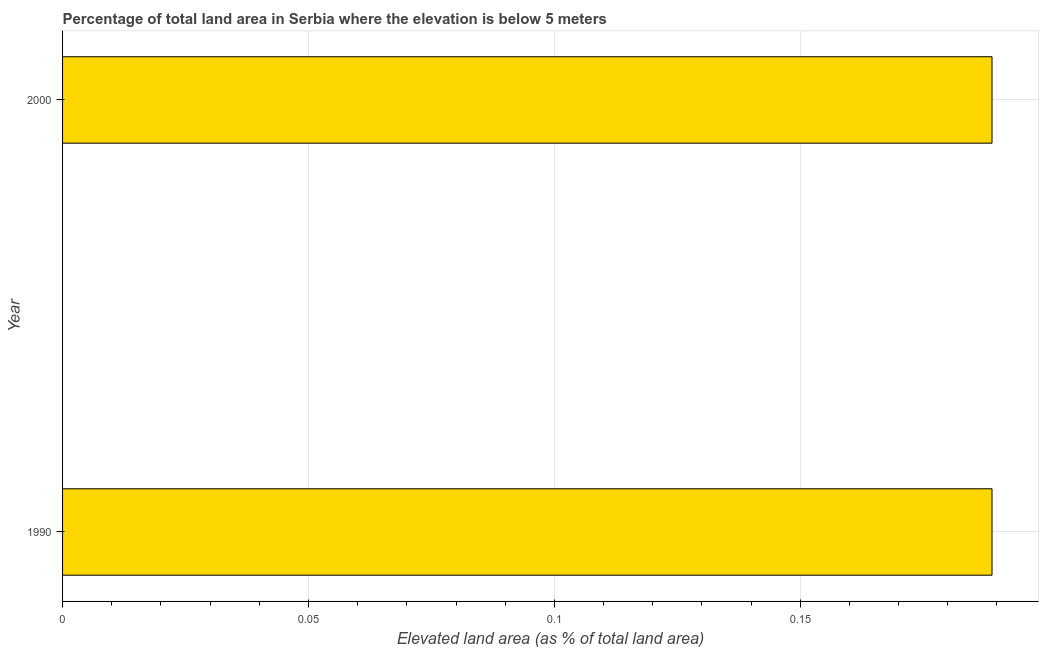Does the graph contain any zero values?
Give a very brief answer. No. What is the title of the graph?
Your answer should be compact. Percentage of total land area in Serbia where the elevation is below 5 meters. What is the label or title of the X-axis?
Make the answer very short. Elevated land area (as % of total land area). What is the total elevated land area in 1990?
Provide a short and direct response. 0.19. Across all years, what is the maximum total elevated land area?
Your answer should be very brief. 0.19. Across all years, what is the minimum total elevated land area?
Keep it short and to the point. 0.19. In which year was the total elevated land area minimum?
Provide a succinct answer. 1990. What is the sum of the total elevated land area?
Provide a short and direct response. 0.38. What is the average total elevated land area per year?
Give a very brief answer. 0.19. What is the median total elevated land area?
Provide a short and direct response. 0.19. What is the ratio of the total elevated land area in 1990 to that in 2000?
Offer a terse response. 1. In how many years, is the total elevated land area greater than the average total elevated land area taken over all years?
Your response must be concise. 0. Are all the bars in the graph horizontal?
Your answer should be very brief. Yes. How many years are there in the graph?
Make the answer very short. 2. What is the difference between two consecutive major ticks on the X-axis?
Give a very brief answer. 0.05. What is the Elevated land area (as % of total land area) of 1990?
Make the answer very short. 0.19. What is the Elevated land area (as % of total land area) of 2000?
Your answer should be very brief. 0.19. What is the difference between the Elevated land area (as % of total land area) in 1990 and 2000?
Ensure brevity in your answer.  0. 